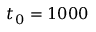Convert formula to latex. <formula><loc_0><loc_0><loc_500><loc_500>t _ { 0 } = 1 0 0 0</formula> 